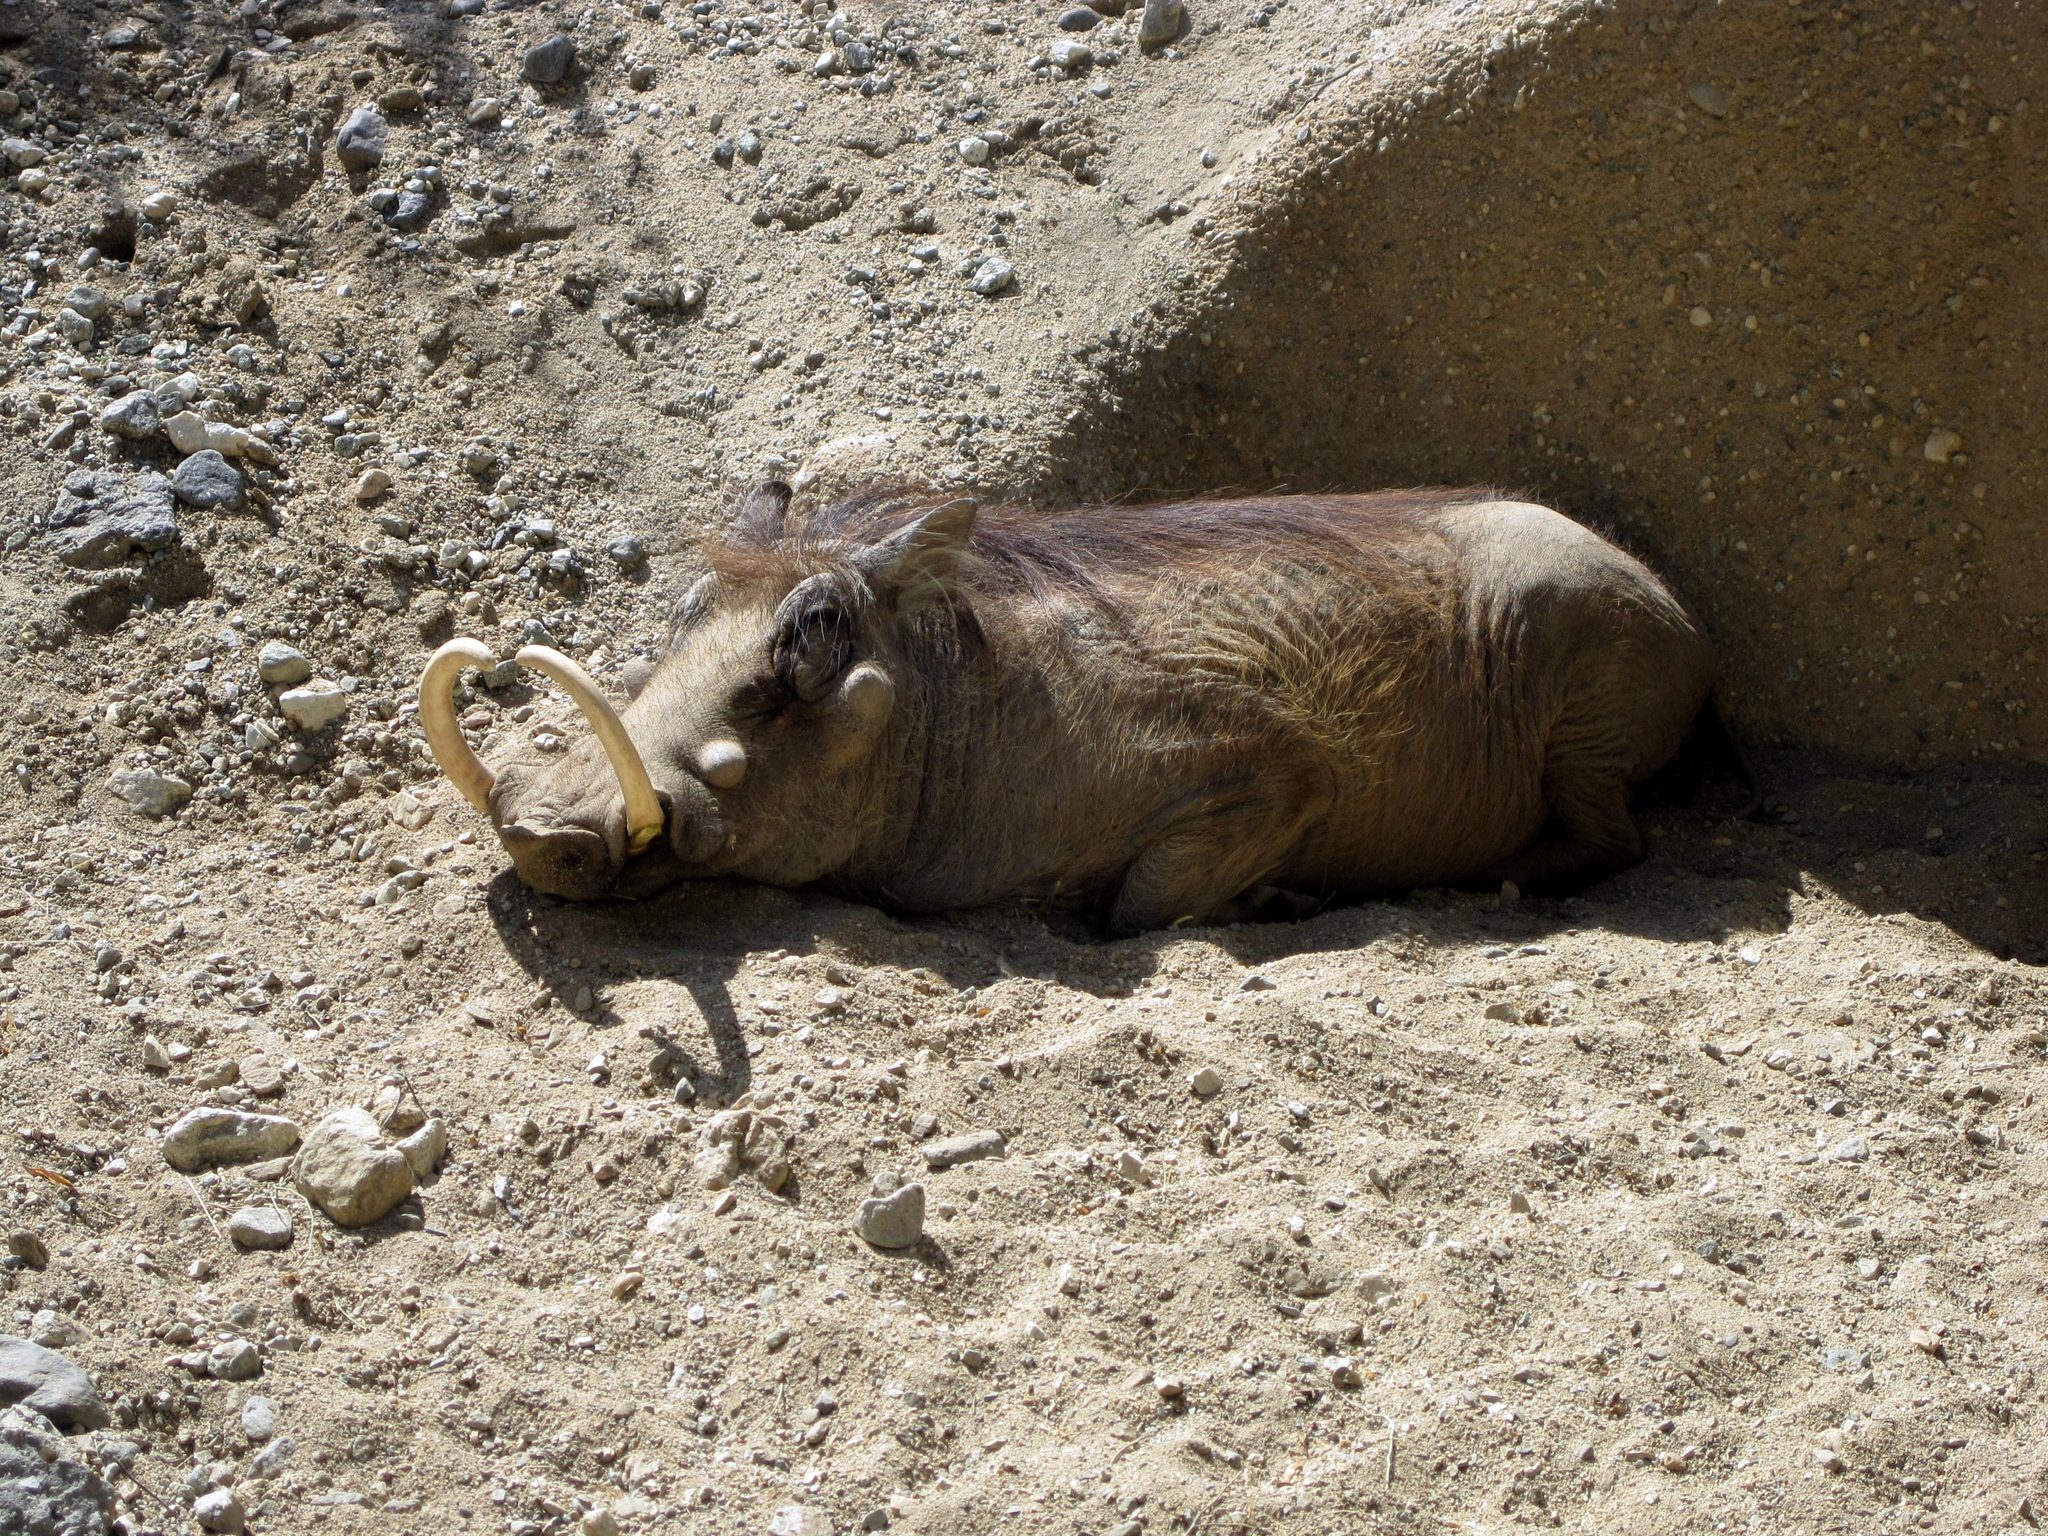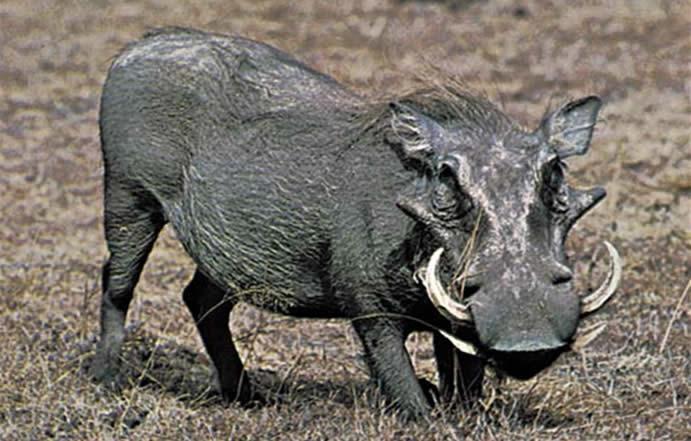The first image is the image on the left, the second image is the image on the right. For the images displayed, is the sentence "One image contains more than one warthog." factually correct? Answer yes or no. No. The first image is the image on the left, the second image is the image on the right. For the images shown, is this caption "We see a baby warthog in one of the images." true? Answer yes or no. No. 